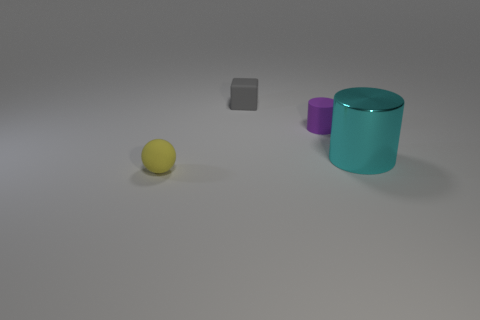What materials do the objects in the image appear to be made of? The objects in the image seem to be made of different materials. The small cube appears to be made of rubber, the ball looks like it could be a plastic or rubber sphere, and the larger cylinder and the small object beside it could be made of glass or a polished stone due to their reflective surfaces. 